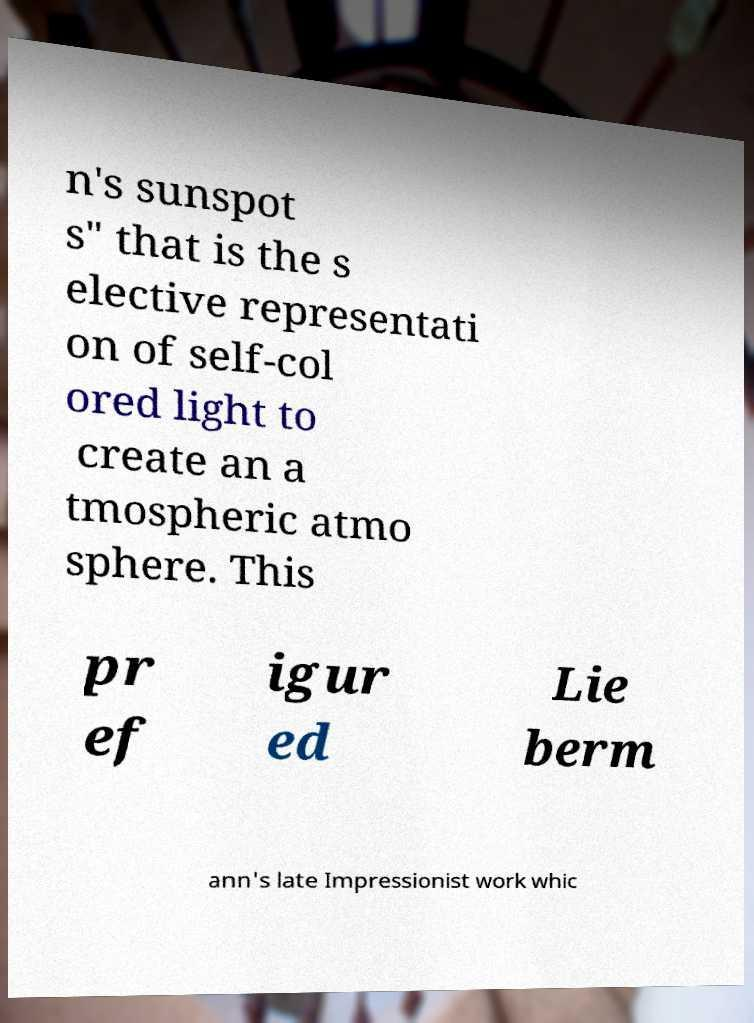Can you read and provide the text displayed in the image?This photo seems to have some interesting text. Can you extract and type it out for me? n's sunspot s" that is the s elective representati on of self-col ored light to create an a tmospheric atmo sphere. This pr ef igur ed Lie berm ann's late Impressionist work whic 